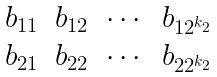Convert formula to latex. <formula><loc_0><loc_0><loc_500><loc_500>\begin{matrix} b _ { 1 1 } & b _ { 1 2 } & \cdots & b _ { 1 2 ^ { k _ { 2 } } } \\ b _ { 2 1 } & b _ { 2 2 } & \cdots & b _ { 2 2 ^ { k _ { 2 } } } \end{matrix}</formula> 